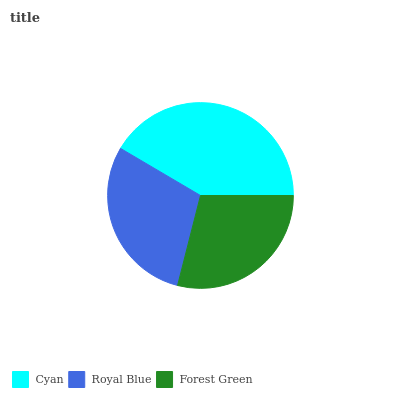Is Forest Green the minimum?
Answer yes or no. Yes. Is Cyan the maximum?
Answer yes or no. Yes. Is Royal Blue the minimum?
Answer yes or no. No. Is Royal Blue the maximum?
Answer yes or no. No. Is Cyan greater than Royal Blue?
Answer yes or no. Yes. Is Royal Blue less than Cyan?
Answer yes or no. Yes. Is Royal Blue greater than Cyan?
Answer yes or no. No. Is Cyan less than Royal Blue?
Answer yes or no. No. Is Royal Blue the high median?
Answer yes or no. Yes. Is Royal Blue the low median?
Answer yes or no. Yes. Is Cyan the high median?
Answer yes or no. No. Is Cyan the low median?
Answer yes or no. No. 